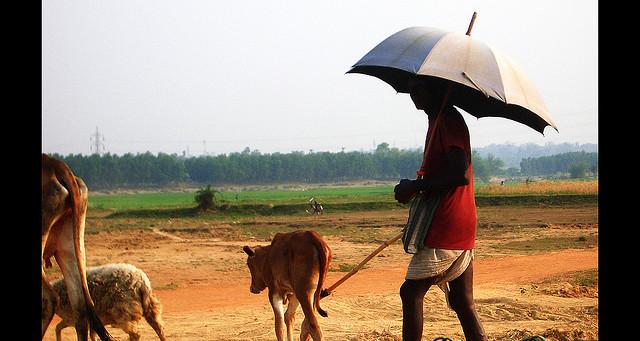Are there trees visible?
Give a very brief answer. Yes. What is the man herding?
Write a very short answer. Livestock. Is it raining in the picture?
Quick response, please. No. 